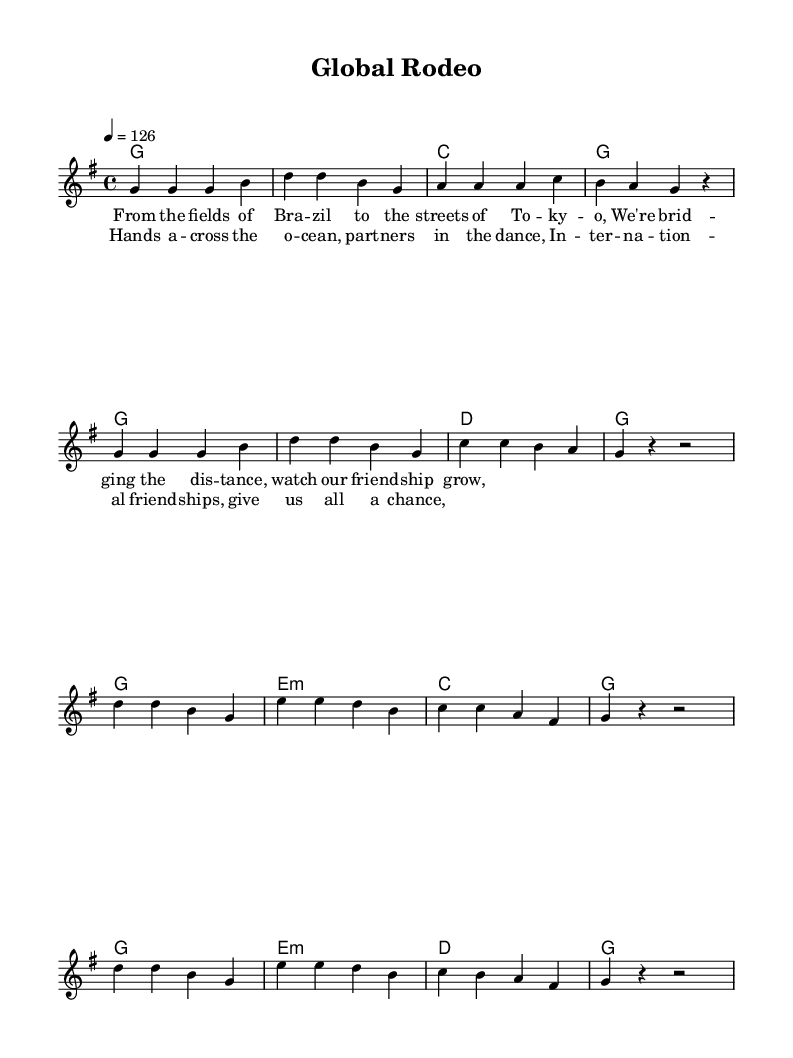What is the key signature of this music? The key signature is G major, which has one sharp (F#). This can be deduced from the global section of the sheet music, where the key is indicated directly.
Answer: G major What is the time signature of this music? The time signature is 4/4, as specified in the global section of the music sheet. In a 4/4 time signature, there are four beats per measure, and each quarter note gets one beat.
Answer: 4/4 What is the tempo marking for the piece? The tempo is set at 126 beats per minute, indicated by the "4 = 126" in the global section of the sheet music. This shows how fast the music should be played.
Answer: 126 How many measures are there in the verse? There are eight measures in the verse section as counted from the melody lines. Each line of notes provided represents a single measure.
Answer: 8 Which musical form does the song primarily utilize? The song utilizes a verse-chorus form. The structure includes a repeated verse followed by a repeated chorus to create a familiar pattern common in country music.
Answer: Verse-Chorus How many chords are used in the chorus? There are four unique chords used in the chorus: G, E minor, C, and D. This is determined by analyzing the harmonies specified for the chorus section.
Answer: 4 What is the overall theme of the lyrics? The overall theme of the lyrics celebrates international friendships and connections, as indicated by expressions like "bridging the distance" and "international friendships."
Answer: International friendships 